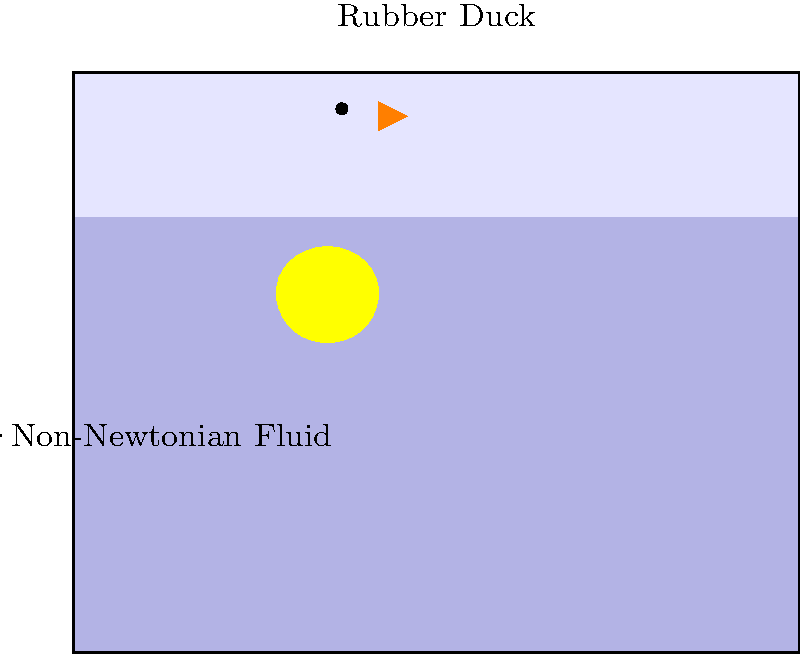A peculiar physicist decides to conduct an experiment with a rubber duck in a bathtub filled with a non-Newtonian fluid. The duck, weighing 0.1 kg, has a volume of $1 \times 10^{-4} \text{ m}^3$. The non-Newtonian fluid has a density of 1100 kg/m³ when at rest. If the duck is gently placed on the fluid's surface, what percentage of the duck's volume will be submerged? (Assume g = 9.8 m/s²)

Bonus: What would happen if the duck were to suddenly belly-flop onto the fluid's surface? Let's approach this step-by-step with a dash of peculiar humor:

1) First, let's recall Archimedes' principle: the buoyant force is equal to the weight of the fluid displaced.

2) The weight of the duck is:
   $$W = mg = 0.1 \text{ kg} \times 9.8 \text{ m/s}^2 = 0.98 \text{ N}$$

3) For the duck to float, this weight must be balanced by the buoyant force:
   $$F_b = \rho_{fluid} \times V_{submerged} \times g$$

4) Setting these equal:
   $$0.98 \text{ N} = 1100 \text{ kg/m}^3 \times V_{submerged} \times 9.8 \text{ m/s}^2$$

5) Solving for $V_{submerged}$:
   $$V_{submerged} = \frac{0.98 \text{ N}}{1100 \text{ kg/m}^3 \times 9.8 \text{ m/s}^2} = 9.09 \times 10^{-5} \text{ m}^3$$

6) To find the percentage submerged, we divide by the total volume:
   $$\text{Percentage submerged} = \frac{9.09 \times 10^{-5} \text{ m}^3}{1 \times 10^{-4} \text{ m}^3} \times 100\% = 90.9\%$$

Bonus: If the duck were to belly-flop onto the surface, it would likely experience a rude awakening! Non-Newtonian fluids exhibit increased viscosity under sudden stress. The fluid might momentarily behave like a solid, potentially leaving our daring duck with a red belly and a bruised ego. It's a stark reminder that in physics, as in comedy, timing is everything!
Answer: 90.9% submerged 